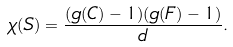Convert formula to latex. <formula><loc_0><loc_0><loc_500><loc_500>\chi ( S ) = \frac { ( g ( C ) - 1 ) ( g ( F ) - 1 ) } { d } .</formula> 